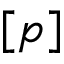Convert formula to latex. <formula><loc_0><loc_0><loc_500><loc_500>{ [ p ] }</formula> 